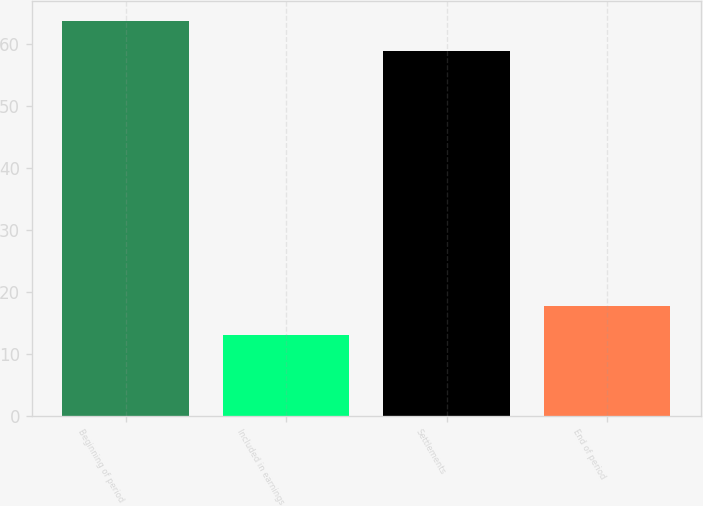<chart> <loc_0><loc_0><loc_500><loc_500><bar_chart><fcel>Beginning of period<fcel>Included in earnings<fcel>Settlements<fcel>End of period<nl><fcel>63.8<fcel>13<fcel>59<fcel>17.8<nl></chart> 